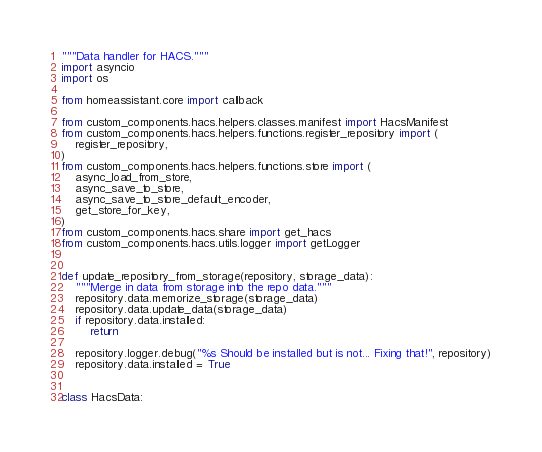<code> <loc_0><loc_0><loc_500><loc_500><_Python_>"""Data handler for HACS."""
import asyncio
import os

from homeassistant.core import callback

from custom_components.hacs.helpers.classes.manifest import HacsManifest
from custom_components.hacs.helpers.functions.register_repository import (
    register_repository,
)
from custom_components.hacs.helpers.functions.store import (
    async_load_from_store,
    async_save_to_store,
    async_save_to_store_default_encoder,
    get_store_for_key,
)
from custom_components.hacs.share import get_hacs
from custom_components.hacs.utils.logger import getLogger


def update_repository_from_storage(repository, storage_data):
    """Merge in data from storage into the repo data."""
    repository.data.memorize_storage(storage_data)
    repository.data.update_data(storage_data)
    if repository.data.installed:
        return

    repository.logger.debug("%s Should be installed but is not... Fixing that!", repository)
    repository.data.installed = True


class HacsData:</code> 